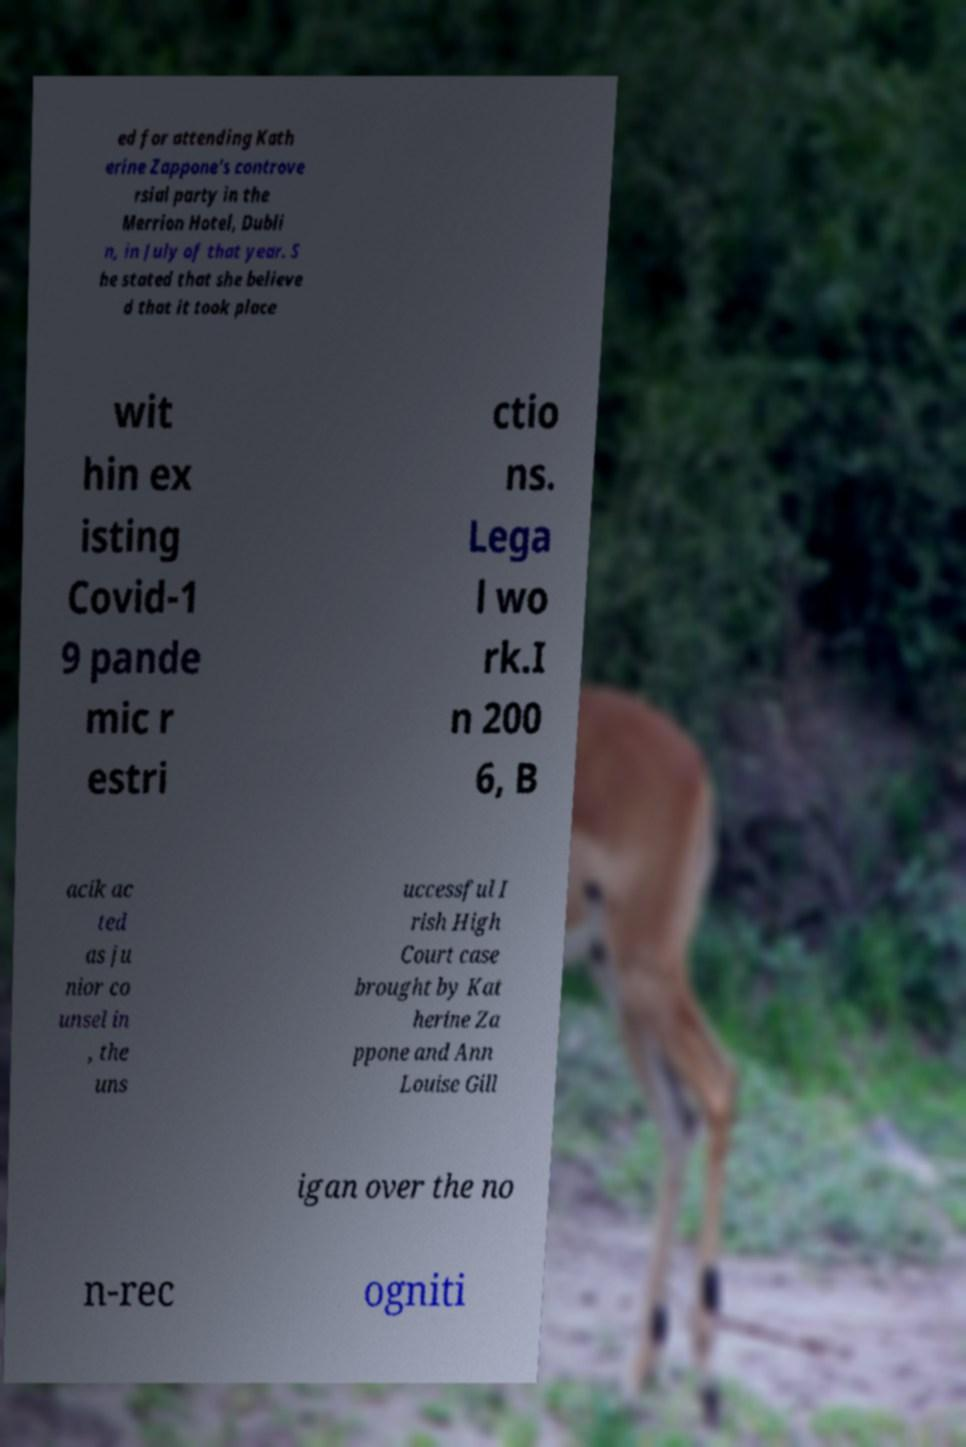Please read and relay the text visible in this image. What does it say? ed for attending Kath erine Zappone's controve rsial party in the Merrion Hotel, Dubli n, in July of that year. S he stated that she believe d that it took place wit hin ex isting Covid-1 9 pande mic r estri ctio ns. Lega l wo rk.I n 200 6, B acik ac ted as ju nior co unsel in , the uns uccessful I rish High Court case brought by Kat herine Za ppone and Ann Louise Gill igan over the no n-rec ogniti 